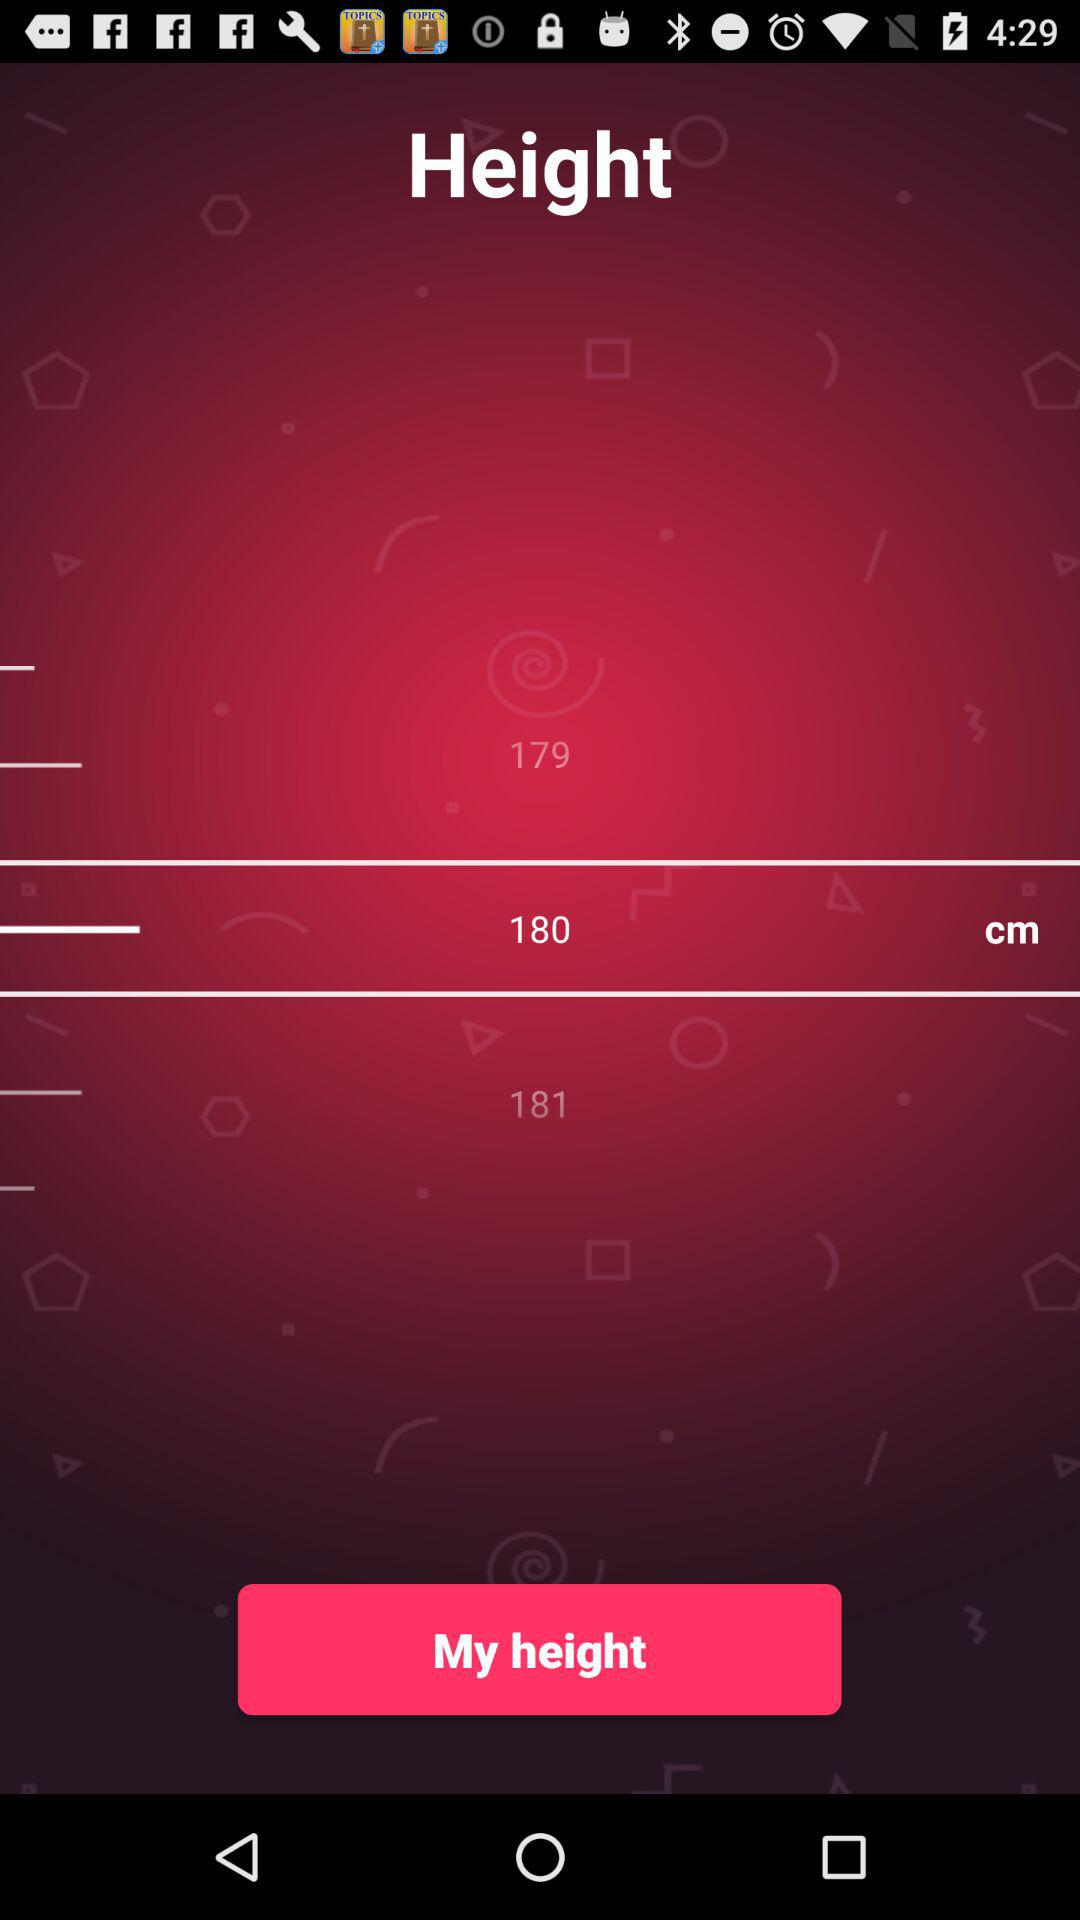What is the height selected in cm? The height selected in cm is 180. 